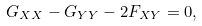Convert formula to latex. <formula><loc_0><loc_0><loc_500><loc_500>G _ { X X } - G _ { Y Y } - 2 F _ { X Y } = 0 ,</formula> 